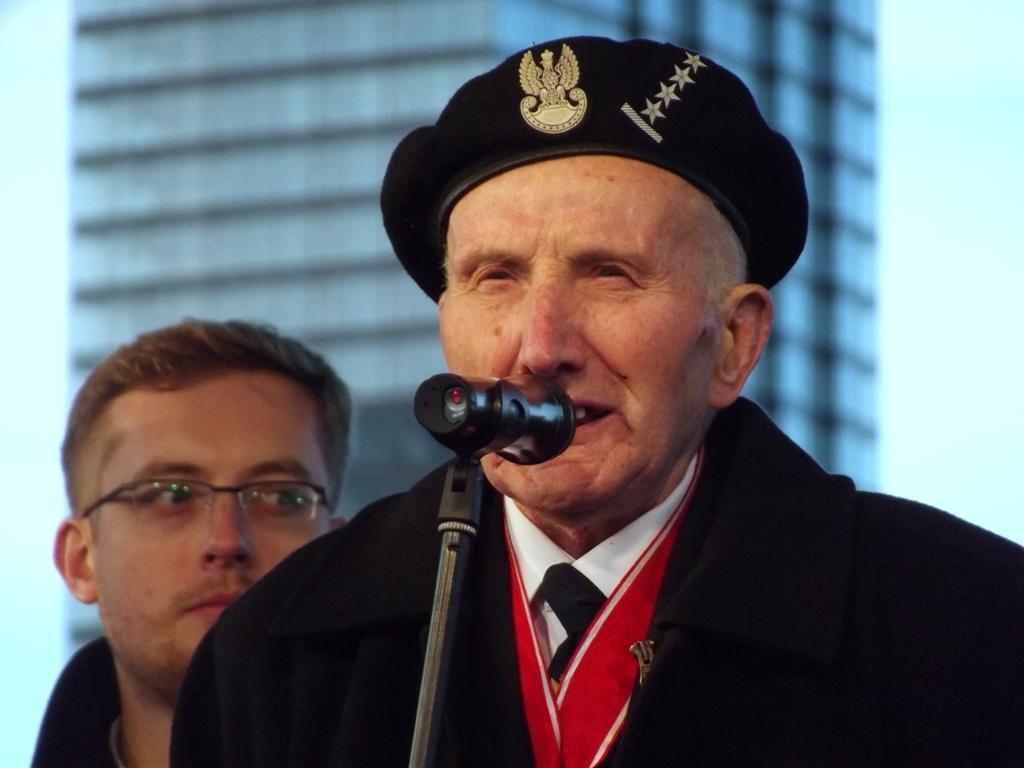In one or two sentences, can you explain what this image depicts? In the center of the image there is a person standing at the mic. In the background we can see person, building and sky. 